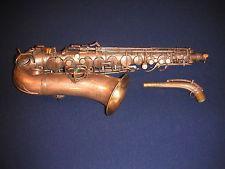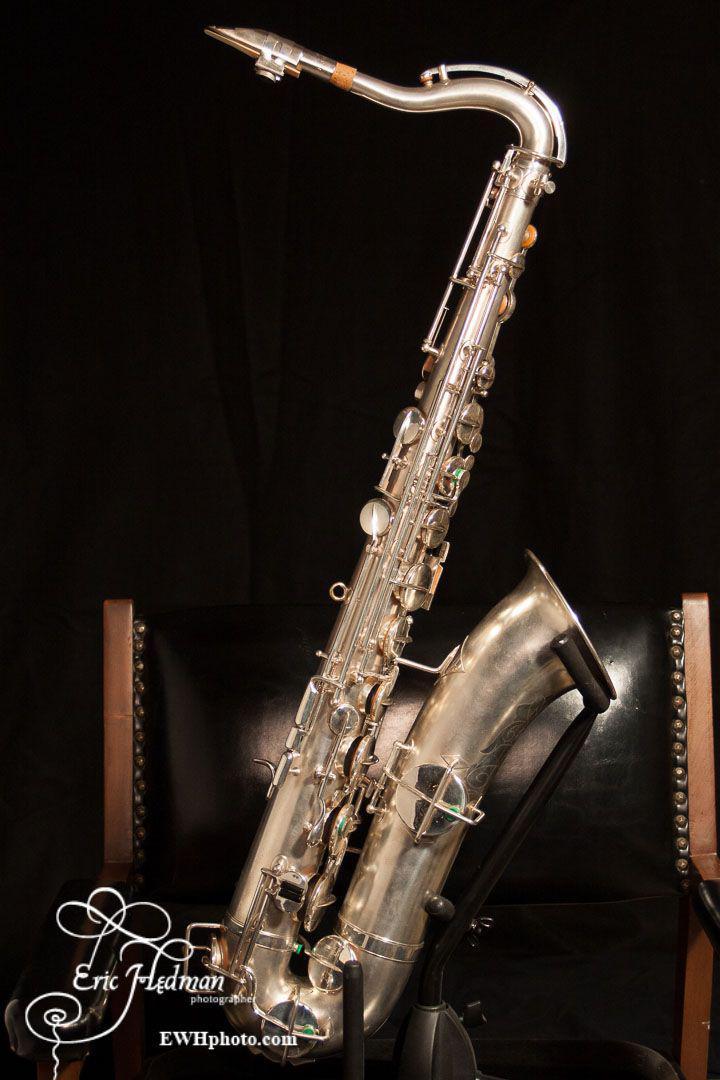The first image is the image on the left, the second image is the image on the right. Considering the images on both sides, is "The left and right image contains the same number saxophone and one if fully put together while the other is missing it's mouthpiece." valid? Answer yes or no. Yes. The first image is the image on the left, the second image is the image on the right. Given the left and right images, does the statement "One image shows a saxophone with mouthpiece attached displayed on folds of blue velvet with its bell turned rightward." hold true? Answer yes or no. No. 